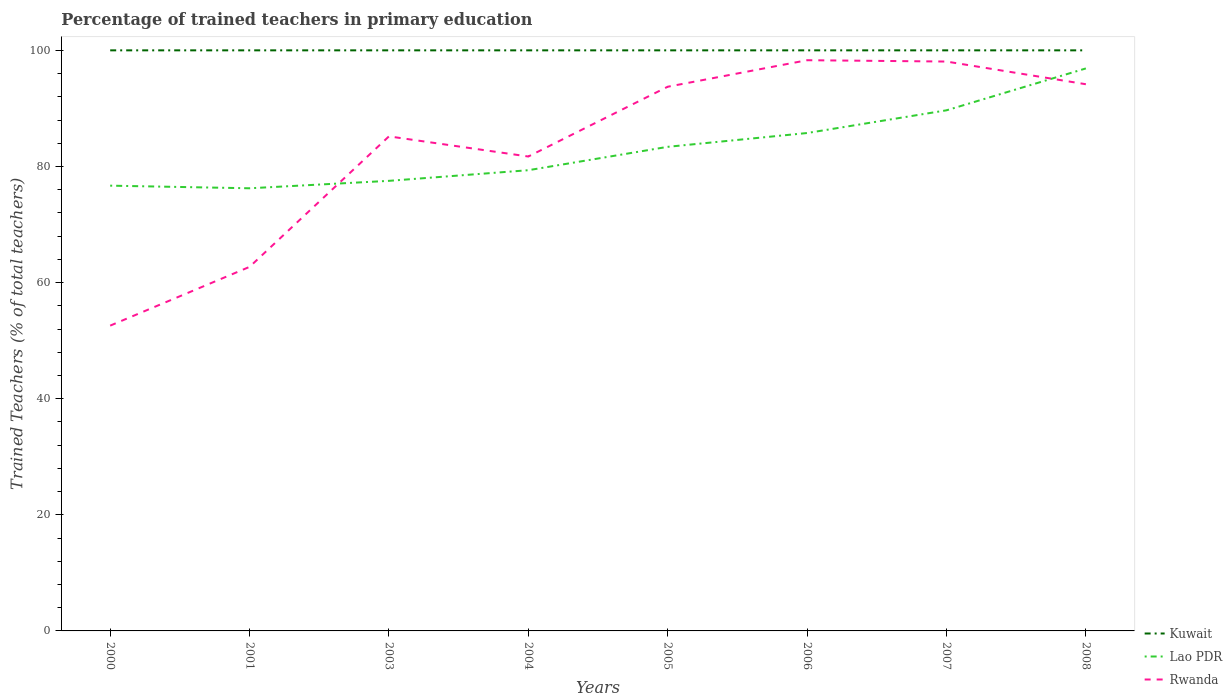Does the line corresponding to Kuwait intersect with the line corresponding to Lao PDR?
Give a very brief answer. No. Is the number of lines equal to the number of legend labels?
Offer a very short reply. Yes. Across all years, what is the maximum percentage of trained teachers in Rwanda?
Ensure brevity in your answer.  52.58. What is the total percentage of trained teachers in Rwanda in the graph?
Make the answer very short. -31.46. What is the difference between the highest and the second highest percentage of trained teachers in Lao PDR?
Your answer should be compact. 20.64. What is the difference between the highest and the lowest percentage of trained teachers in Kuwait?
Make the answer very short. 0. How many lines are there?
Make the answer very short. 3. Are the values on the major ticks of Y-axis written in scientific E-notation?
Offer a terse response. No. Where does the legend appear in the graph?
Make the answer very short. Bottom right. What is the title of the graph?
Offer a very short reply. Percentage of trained teachers in primary education. Does "Latin America(all income levels)" appear as one of the legend labels in the graph?
Give a very brief answer. No. What is the label or title of the Y-axis?
Keep it short and to the point. Trained Teachers (% of total teachers). What is the Trained Teachers (% of total teachers) in Kuwait in 2000?
Offer a very short reply. 100. What is the Trained Teachers (% of total teachers) of Lao PDR in 2000?
Provide a succinct answer. 76.69. What is the Trained Teachers (% of total teachers) of Rwanda in 2000?
Make the answer very short. 52.58. What is the Trained Teachers (% of total teachers) in Kuwait in 2001?
Make the answer very short. 100. What is the Trained Teachers (% of total teachers) in Lao PDR in 2001?
Your answer should be very brief. 76.24. What is the Trained Teachers (% of total teachers) in Rwanda in 2001?
Keep it short and to the point. 62.7. What is the Trained Teachers (% of total teachers) in Kuwait in 2003?
Ensure brevity in your answer.  100. What is the Trained Teachers (% of total teachers) in Lao PDR in 2003?
Offer a very short reply. 77.52. What is the Trained Teachers (% of total teachers) of Rwanda in 2003?
Provide a short and direct response. 85.18. What is the Trained Teachers (% of total teachers) in Lao PDR in 2004?
Offer a very short reply. 79.35. What is the Trained Teachers (% of total teachers) in Rwanda in 2004?
Offer a terse response. 81.71. What is the Trained Teachers (% of total teachers) of Lao PDR in 2005?
Give a very brief answer. 83.38. What is the Trained Teachers (% of total teachers) of Rwanda in 2005?
Give a very brief answer. 93.73. What is the Trained Teachers (% of total teachers) of Lao PDR in 2006?
Ensure brevity in your answer.  85.76. What is the Trained Teachers (% of total teachers) in Rwanda in 2006?
Keep it short and to the point. 98.3. What is the Trained Teachers (% of total teachers) of Kuwait in 2007?
Offer a terse response. 100. What is the Trained Teachers (% of total teachers) in Lao PDR in 2007?
Keep it short and to the point. 89.67. What is the Trained Teachers (% of total teachers) of Rwanda in 2007?
Offer a very short reply. 98.07. What is the Trained Teachers (% of total teachers) in Kuwait in 2008?
Provide a succinct answer. 100. What is the Trained Teachers (% of total teachers) of Lao PDR in 2008?
Provide a short and direct response. 96.89. What is the Trained Teachers (% of total teachers) in Rwanda in 2008?
Provide a succinct answer. 94.16. Across all years, what is the maximum Trained Teachers (% of total teachers) of Lao PDR?
Offer a very short reply. 96.89. Across all years, what is the maximum Trained Teachers (% of total teachers) of Rwanda?
Your answer should be compact. 98.3. Across all years, what is the minimum Trained Teachers (% of total teachers) of Lao PDR?
Give a very brief answer. 76.24. Across all years, what is the minimum Trained Teachers (% of total teachers) in Rwanda?
Ensure brevity in your answer.  52.58. What is the total Trained Teachers (% of total teachers) of Kuwait in the graph?
Your response must be concise. 800. What is the total Trained Teachers (% of total teachers) in Lao PDR in the graph?
Provide a short and direct response. 665.51. What is the total Trained Teachers (% of total teachers) in Rwanda in the graph?
Keep it short and to the point. 666.45. What is the difference between the Trained Teachers (% of total teachers) in Kuwait in 2000 and that in 2001?
Ensure brevity in your answer.  0. What is the difference between the Trained Teachers (% of total teachers) of Lao PDR in 2000 and that in 2001?
Keep it short and to the point. 0.45. What is the difference between the Trained Teachers (% of total teachers) of Rwanda in 2000 and that in 2001?
Offer a terse response. -10.12. What is the difference between the Trained Teachers (% of total teachers) of Lao PDR in 2000 and that in 2003?
Your answer should be very brief. -0.83. What is the difference between the Trained Teachers (% of total teachers) in Rwanda in 2000 and that in 2003?
Offer a very short reply. -32.6. What is the difference between the Trained Teachers (% of total teachers) in Lao PDR in 2000 and that in 2004?
Offer a terse response. -2.66. What is the difference between the Trained Teachers (% of total teachers) of Rwanda in 2000 and that in 2004?
Ensure brevity in your answer.  -29.13. What is the difference between the Trained Teachers (% of total teachers) in Lao PDR in 2000 and that in 2005?
Keep it short and to the point. -6.69. What is the difference between the Trained Teachers (% of total teachers) in Rwanda in 2000 and that in 2005?
Provide a succinct answer. -41.15. What is the difference between the Trained Teachers (% of total teachers) in Lao PDR in 2000 and that in 2006?
Give a very brief answer. -9.07. What is the difference between the Trained Teachers (% of total teachers) of Rwanda in 2000 and that in 2006?
Keep it short and to the point. -45.72. What is the difference between the Trained Teachers (% of total teachers) in Lao PDR in 2000 and that in 2007?
Ensure brevity in your answer.  -12.98. What is the difference between the Trained Teachers (% of total teachers) in Rwanda in 2000 and that in 2007?
Provide a succinct answer. -45.49. What is the difference between the Trained Teachers (% of total teachers) of Kuwait in 2000 and that in 2008?
Your answer should be very brief. 0. What is the difference between the Trained Teachers (% of total teachers) of Lao PDR in 2000 and that in 2008?
Provide a short and direct response. -20.19. What is the difference between the Trained Teachers (% of total teachers) in Rwanda in 2000 and that in 2008?
Keep it short and to the point. -41.58. What is the difference between the Trained Teachers (% of total teachers) of Kuwait in 2001 and that in 2003?
Keep it short and to the point. 0. What is the difference between the Trained Teachers (% of total teachers) in Lao PDR in 2001 and that in 2003?
Offer a terse response. -1.28. What is the difference between the Trained Teachers (% of total teachers) in Rwanda in 2001 and that in 2003?
Ensure brevity in your answer.  -22.48. What is the difference between the Trained Teachers (% of total teachers) of Kuwait in 2001 and that in 2004?
Make the answer very short. 0. What is the difference between the Trained Teachers (% of total teachers) of Lao PDR in 2001 and that in 2004?
Ensure brevity in your answer.  -3.11. What is the difference between the Trained Teachers (% of total teachers) in Rwanda in 2001 and that in 2004?
Ensure brevity in your answer.  -19.01. What is the difference between the Trained Teachers (% of total teachers) in Lao PDR in 2001 and that in 2005?
Give a very brief answer. -7.14. What is the difference between the Trained Teachers (% of total teachers) of Rwanda in 2001 and that in 2005?
Provide a succinct answer. -31.03. What is the difference between the Trained Teachers (% of total teachers) of Kuwait in 2001 and that in 2006?
Offer a very short reply. 0. What is the difference between the Trained Teachers (% of total teachers) in Lao PDR in 2001 and that in 2006?
Provide a succinct answer. -9.52. What is the difference between the Trained Teachers (% of total teachers) in Rwanda in 2001 and that in 2006?
Keep it short and to the point. -35.59. What is the difference between the Trained Teachers (% of total teachers) in Kuwait in 2001 and that in 2007?
Make the answer very short. 0. What is the difference between the Trained Teachers (% of total teachers) of Lao PDR in 2001 and that in 2007?
Provide a succinct answer. -13.43. What is the difference between the Trained Teachers (% of total teachers) of Rwanda in 2001 and that in 2007?
Your response must be concise. -35.37. What is the difference between the Trained Teachers (% of total teachers) in Kuwait in 2001 and that in 2008?
Offer a terse response. 0. What is the difference between the Trained Teachers (% of total teachers) of Lao PDR in 2001 and that in 2008?
Give a very brief answer. -20.64. What is the difference between the Trained Teachers (% of total teachers) in Rwanda in 2001 and that in 2008?
Provide a short and direct response. -31.46. What is the difference between the Trained Teachers (% of total teachers) in Kuwait in 2003 and that in 2004?
Keep it short and to the point. 0. What is the difference between the Trained Teachers (% of total teachers) in Lao PDR in 2003 and that in 2004?
Your response must be concise. -1.83. What is the difference between the Trained Teachers (% of total teachers) in Rwanda in 2003 and that in 2004?
Provide a succinct answer. 3.47. What is the difference between the Trained Teachers (% of total teachers) in Lao PDR in 2003 and that in 2005?
Ensure brevity in your answer.  -5.86. What is the difference between the Trained Teachers (% of total teachers) in Rwanda in 2003 and that in 2005?
Give a very brief answer. -8.55. What is the difference between the Trained Teachers (% of total teachers) in Lao PDR in 2003 and that in 2006?
Your answer should be very brief. -8.24. What is the difference between the Trained Teachers (% of total teachers) of Rwanda in 2003 and that in 2006?
Your answer should be very brief. -13.12. What is the difference between the Trained Teachers (% of total teachers) of Lao PDR in 2003 and that in 2007?
Your answer should be very brief. -12.15. What is the difference between the Trained Teachers (% of total teachers) of Rwanda in 2003 and that in 2007?
Make the answer very short. -12.89. What is the difference between the Trained Teachers (% of total teachers) in Kuwait in 2003 and that in 2008?
Ensure brevity in your answer.  0. What is the difference between the Trained Teachers (% of total teachers) of Lao PDR in 2003 and that in 2008?
Offer a very short reply. -19.36. What is the difference between the Trained Teachers (% of total teachers) of Rwanda in 2003 and that in 2008?
Your answer should be very brief. -8.98. What is the difference between the Trained Teachers (% of total teachers) of Lao PDR in 2004 and that in 2005?
Your response must be concise. -4.03. What is the difference between the Trained Teachers (% of total teachers) in Rwanda in 2004 and that in 2005?
Provide a short and direct response. -12.02. What is the difference between the Trained Teachers (% of total teachers) of Lao PDR in 2004 and that in 2006?
Your answer should be compact. -6.41. What is the difference between the Trained Teachers (% of total teachers) of Rwanda in 2004 and that in 2006?
Provide a short and direct response. -16.59. What is the difference between the Trained Teachers (% of total teachers) of Lao PDR in 2004 and that in 2007?
Your answer should be compact. -10.32. What is the difference between the Trained Teachers (% of total teachers) of Rwanda in 2004 and that in 2007?
Keep it short and to the point. -16.36. What is the difference between the Trained Teachers (% of total teachers) of Kuwait in 2004 and that in 2008?
Ensure brevity in your answer.  0. What is the difference between the Trained Teachers (% of total teachers) of Lao PDR in 2004 and that in 2008?
Offer a terse response. -17.53. What is the difference between the Trained Teachers (% of total teachers) of Rwanda in 2004 and that in 2008?
Offer a terse response. -12.45. What is the difference between the Trained Teachers (% of total teachers) in Kuwait in 2005 and that in 2006?
Provide a succinct answer. 0. What is the difference between the Trained Teachers (% of total teachers) of Lao PDR in 2005 and that in 2006?
Provide a succinct answer. -2.38. What is the difference between the Trained Teachers (% of total teachers) in Rwanda in 2005 and that in 2006?
Provide a succinct answer. -4.57. What is the difference between the Trained Teachers (% of total teachers) of Kuwait in 2005 and that in 2007?
Offer a terse response. 0. What is the difference between the Trained Teachers (% of total teachers) in Lao PDR in 2005 and that in 2007?
Provide a short and direct response. -6.29. What is the difference between the Trained Teachers (% of total teachers) of Rwanda in 2005 and that in 2007?
Ensure brevity in your answer.  -4.34. What is the difference between the Trained Teachers (% of total teachers) in Lao PDR in 2005 and that in 2008?
Ensure brevity in your answer.  -13.5. What is the difference between the Trained Teachers (% of total teachers) of Rwanda in 2005 and that in 2008?
Your response must be concise. -0.43. What is the difference between the Trained Teachers (% of total teachers) of Lao PDR in 2006 and that in 2007?
Make the answer very short. -3.91. What is the difference between the Trained Teachers (% of total teachers) of Rwanda in 2006 and that in 2007?
Give a very brief answer. 0.23. What is the difference between the Trained Teachers (% of total teachers) in Kuwait in 2006 and that in 2008?
Offer a terse response. 0. What is the difference between the Trained Teachers (% of total teachers) of Lao PDR in 2006 and that in 2008?
Your response must be concise. -11.13. What is the difference between the Trained Teachers (% of total teachers) of Rwanda in 2006 and that in 2008?
Keep it short and to the point. 4.14. What is the difference between the Trained Teachers (% of total teachers) of Kuwait in 2007 and that in 2008?
Provide a succinct answer. 0. What is the difference between the Trained Teachers (% of total teachers) in Lao PDR in 2007 and that in 2008?
Offer a terse response. -7.22. What is the difference between the Trained Teachers (% of total teachers) in Rwanda in 2007 and that in 2008?
Offer a very short reply. 3.91. What is the difference between the Trained Teachers (% of total teachers) in Kuwait in 2000 and the Trained Teachers (% of total teachers) in Lao PDR in 2001?
Keep it short and to the point. 23.76. What is the difference between the Trained Teachers (% of total teachers) in Kuwait in 2000 and the Trained Teachers (% of total teachers) in Rwanda in 2001?
Provide a short and direct response. 37.3. What is the difference between the Trained Teachers (% of total teachers) of Lao PDR in 2000 and the Trained Teachers (% of total teachers) of Rwanda in 2001?
Make the answer very short. 13.99. What is the difference between the Trained Teachers (% of total teachers) of Kuwait in 2000 and the Trained Teachers (% of total teachers) of Lao PDR in 2003?
Make the answer very short. 22.48. What is the difference between the Trained Teachers (% of total teachers) in Kuwait in 2000 and the Trained Teachers (% of total teachers) in Rwanda in 2003?
Your answer should be compact. 14.82. What is the difference between the Trained Teachers (% of total teachers) in Lao PDR in 2000 and the Trained Teachers (% of total teachers) in Rwanda in 2003?
Give a very brief answer. -8.49. What is the difference between the Trained Teachers (% of total teachers) in Kuwait in 2000 and the Trained Teachers (% of total teachers) in Lao PDR in 2004?
Your response must be concise. 20.65. What is the difference between the Trained Teachers (% of total teachers) of Kuwait in 2000 and the Trained Teachers (% of total teachers) of Rwanda in 2004?
Your answer should be compact. 18.29. What is the difference between the Trained Teachers (% of total teachers) of Lao PDR in 2000 and the Trained Teachers (% of total teachers) of Rwanda in 2004?
Give a very brief answer. -5.02. What is the difference between the Trained Teachers (% of total teachers) of Kuwait in 2000 and the Trained Teachers (% of total teachers) of Lao PDR in 2005?
Provide a short and direct response. 16.62. What is the difference between the Trained Teachers (% of total teachers) of Kuwait in 2000 and the Trained Teachers (% of total teachers) of Rwanda in 2005?
Your response must be concise. 6.27. What is the difference between the Trained Teachers (% of total teachers) in Lao PDR in 2000 and the Trained Teachers (% of total teachers) in Rwanda in 2005?
Your response must be concise. -17.04. What is the difference between the Trained Teachers (% of total teachers) of Kuwait in 2000 and the Trained Teachers (% of total teachers) of Lao PDR in 2006?
Your answer should be compact. 14.24. What is the difference between the Trained Teachers (% of total teachers) in Kuwait in 2000 and the Trained Teachers (% of total teachers) in Rwanda in 2006?
Your answer should be very brief. 1.7. What is the difference between the Trained Teachers (% of total teachers) in Lao PDR in 2000 and the Trained Teachers (% of total teachers) in Rwanda in 2006?
Provide a short and direct response. -21.61. What is the difference between the Trained Teachers (% of total teachers) of Kuwait in 2000 and the Trained Teachers (% of total teachers) of Lao PDR in 2007?
Keep it short and to the point. 10.33. What is the difference between the Trained Teachers (% of total teachers) of Kuwait in 2000 and the Trained Teachers (% of total teachers) of Rwanda in 2007?
Give a very brief answer. 1.93. What is the difference between the Trained Teachers (% of total teachers) in Lao PDR in 2000 and the Trained Teachers (% of total teachers) in Rwanda in 2007?
Offer a terse response. -21.38. What is the difference between the Trained Teachers (% of total teachers) of Kuwait in 2000 and the Trained Teachers (% of total teachers) of Lao PDR in 2008?
Provide a succinct answer. 3.11. What is the difference between the Trained Teachers (% of total teachers) in Kuwait in 2000 and the Trained Teachers (% of total teachers) in Rwanda in 2008?
Offer a very short reply. 5.84. What is the difference between the Trained Teachers (% of total teachers) in Lao PDR in 2000 and the Trained Teachers (% of total teachers) in Rwanda in 2008?
Your response must be concise. -17.47. What is the difference between the Trained Teachers (% of total teachers) of Kuwait in 2001 and the Trained Teachers (% of total teachers) of Lao PDR in 2003?
Keep it short and to the point. 22.48. What is the difference between the Trained Teachers (% of total teachers) in Kuwait in 2001 and the Trained Teachers (% of total teachers) in Rwanda in 2003?
Your answer should be compact. 14.82. What is the difference between the Trained Teachers (% of total teachers) of Lao PDR in 2001 and the Trained Teachers (% of total teachers) of Rwanda in 2003?
Make the answer very short. -8.94. What is the difference between the Trained Teachers (% of total teachers) in Kuwait in 2001 and the Trained Teachers (% of total teachers) in Lao PDR in 2004?
Provide a short and direct response. 20.65. What is the difference between the Trained Teachers (% of total teachers) in Kuwait in 2001 and the Trained Teachers (% of total teachers) in Rwanda in 2004?
Make the answer very short. 18.29. What is the difference between the Trained Teachers (% of total teachers) in Lao PDR in 2001 and the Trained Teachers (% of total teachers) in Rwanda in 2004?
Keep it short and to the point. -5.47. What is the difference between the Trained Teachers (% of total teachers) in Kuwait in 2001 and the Trained Teachers (% of total teachers) in Lao PDR in 2005?
Your answer should be compact. 16.62. What is the difference between the Trained Teachers (% of total teachers) of Kuwait in 2001 and the Trained Teachers (% of total teachers) of Rwanda in 2005?
Make the answer very short. 6.27. What is the difference between the Trained Teachers (% of total teachers) of Lao PDR in 2001 and the Trained Teachers (% of total teachers) of Rwanda in 2005?
Keep it short and to the point. -17.49. What is the difference between the Trained Teachers (% of total teachers) in Kuwait in 2001 and the Trained Teachers (% of total teachers) in Lao PDR in 2006?
Provide a succinct answer. 14.24. What is the difference between the Trained Teachers (% of total teachers) in Kuwait in 2001 and the Trained Teachers (% of total teachers) in Rwanda in 2006?
Keep it short and to the point. 1.7. What is the difference between the Trained Teachers (% of total teachers) in Lao PDR in 2001 and the Trained Teachers (% of total teachers) in Rwanda in 2006?
Keep it short and to the point. -22.06. What is the difference between the Trained Teachers (% of total teachers) of Kuwait in 2001 and the Trained Teachers (% of total teachers) of Lao PDR in 2007?
Your answer should be very brief. 10.33. What is the difference between the Trained Teachers (% of total teachers) of Kuwait in 2001 and the Trained Teachers (% of total teachers) of Rwanda in 2007?
Make the answer very short. 1.93. What is the difference between the Trained Teachers (% of total teachers) of Lao PDR in 2001 and the Trained Teachers (% of total teachers) of Rwanda in 2007?
Offer a terse response. -21.83. What is the difference between the Trained Teachers (% of total teachers) in Kuwait in 2001 and the Trained Teachers (% of total teachers) in Lao PDR in 2008?
Offer a terse response. 3.11. What is the difference between the Trained Teachers (% of total teachers) of Kuwait in 2001 and the Trained Teachers (% of total teachers) of Rwanda in 2008?
Keep it short and to the point. 5.84. What is the difference between the Trained Teachers (% of total teachers) in Lao PDR in 2001 and the Trained Teachers (% of total teachers) in Rwanda in 2008?
Ensure brevity in your answer.  -17.92. What is the difference between the Trained Teachers (% of total teachers) in Kuwait in 2003 and the Trained Teachers (% of total teachers) in Lao PDR in 2004?
Give a very brief answer. 20.65. What is the difference between the Trained Teachers (% of total teachers) in Kuwait in 2003 and the Trained Teachers (% of total teachers) in Rwanda in 2004?
Your answer should be very brief. 18.29. What is the difference between the Trained Teachers (% of total teachers) of Lao PDR in 2003 and the Trained Teachers (% of total teachers) of Rwanda in 2004?
Keep it short and to the point. -4.19. What is the difference between the Trained Teachers (% of total teachers) in Kuwait in 2003 and the Trained Teachers (% of total teachers) in Lao PDR in 2005?
Provide a short and direct response. 16.62. What is the difference between the Trained Teachers (% of total teachers) of Kuwait in 2003 and the Trained Teachers (% of total teachers) of Rwanda in 2005?
Ensure brevity in your answer.  6.27. What is the difference between the Trained Teachers (% of total teachers) of Lao PDR in 2003 and the Trained Teachers (% of total teachers) of Rwanda in 2005?
Ensure brevity in your answer.  -16.21. What is the difference between the Trained Teachers (% of total teachers) of Kuwait in 2003 and the Trained Teachers (% of total teachers) of Lao PDR in 2006?
Offer a terse response. 14.24. What is the difference between the Trained Teachers (% of total teachers) of Kuwait in 2003 and the Trained Teachers (% of total teachers) of Rwanda in 2006?
Your answer should be compact. 1.7. What is the difference between the Trained Teachers (% of total teachers) in Lao PDR in 2003 and the Trained Teachers (% of total teachers) in Rwanda in 2006?
Make the answer very short. -20.78. What is the difference between the Trained Teachers (% of total teachers) in Kuwait in 2003 and the Trained Teachers (% of total teachers) in Lao PDR in 2007?
Ensure brevity in your answer.  10.33. What is the difference between the Trained Teachers (% of total teachers) of Kuwait in 2003 and the Trained Teachers (% of total teachers) of Rwanda in 2007?
Offer a very short reply. 1.93. What is the difference between the Trained Teachers (% of total teachers) of Lao PDR in 2003 and the Trained Teachers (% of total teachers) of Rwanda in 2007?
Your answer should be very brief. -20.55. What is the difference between the Trained Teachers (% of total teachers) in Kuwait in 2003 and the Trained Teachers (% of total teachers) in Lao PDR in 2008?
Offer a very short reply. 3.11. What is the difference between the Trained Teachers (% of total teachers) in Kuwait in 2003 and the Trained Teachers (% of total teachers) in Rwanda in 2008?
Keep it short and to the point. 5.84. What is the difference between the Trained Teachers (% of total teachers) in Lao PDR in 2003 and the Trained Teachers (% of total teachers) in Rwanda in 2008?
Your answer should be compact. -16.64. What is the difference between the Trained Teachers (% of total teachers) in Kuwait in 2004 and the Trained Teachers (% of total teachers) in Lao PDR in 2005?
Your answer should be compact. 16.62. What is the difference between the Trained Teachers (% of total teachers) of Kuwait in 2004 and the Trained Teachers (% of total teachers) of Rwanda in 2005?
Ensure brevity in your answer.  6.27. What is the difference between the Trained Teachers (% of total teachers) in Lao PDR in 2004 and the Trained Teachers (% of total teachers) in Rwanda in 2005?
Keep it short and to the point. -14.38. What is the difference between the Trained Teachers (% of total teachers) in Kuwait in 2004 and the Trained Teachers (% of total teachers) in Lao PDR in 2006?
Offer a terse response. 14.24. What is the difference between the Trained Teachers (% of total teachers) of Kuwait in 2004 and the Trained Teachers (% of total teachers) of Rwanda in 2006?
Your response must be concise. 1.7. What is the difference between the Trained Teachers (% of total teachers) in Lao PDR in 2004 and the Trained Teachers (% of total teachers) in Rwanda in 2006?
Offer a terse response. -18.95. What is the difference between the Trained Teachers (% of total teachers) of Kuwait in 2004 and the Trained Teachers (% of total teachers) of Lao PDR in 2007?
Make the answer very short. 10.33. What is the difference between the Trained Teachers (% of total teachers) of Kuwait in 2004 and the Trained Teachers (% of total teachers) of Rwanda in 2007?
Your answer should be very brief. 1.93. What is the difference between the Trained Teachers (% of total teachers) in Lao PDR in 2004 and the Trained Teachers (% of total teachers) in Rwanda in 2007?
Make the answer very short. -18.72. What is the difference between the Trained Teachers (% of total teachers) in Kuwait in 2004 and the Trained Teachers (% of total teachers) in Lao PDR in 2008?
Provide a short and direct response. 3.11. What is the difference between the Trained Teachers (% of total teachers) of Kuwait in 2004 and the Trained Teachers (% of total teachers) of Rwanda in 2008?
Provide a short and direct response. 5.84. What is the difference between the Trained Teachers (% of total teachers) in Lao PDR in 2004 and the Trained Teachers (% of total teachers) in Rwanda in 2008?
Make the answer very short. -14.81. What is the difference between the Trained Teachers (% of total teachers) of Kuwait in 2005 and the Trained Teachers (% of total teachers) of Lao PDR in 2006?
Offer a very short reply. 14.24. What is the difference between the Trained Teachers (% of total teachers) of Kuwait in 2005 and the Trained Teachers (% of total teachers) of Rwanda in 2006?
Provide a short and direct response. 1.7. What is the difference between the Trained Teachers (% of total teachers) in Lao PDR in 2005 and the Trained Teachers (% of total teachers) in Rwanda in 2006?
Keep it short and to the point. -14.92. What is the difference between the Trained Teachers (% of total teachers) of Kuwait in 2005 and the Trained Teachers (% of total teachers) of Lao PDR in 2007?
Ensure brevity in your answer.  10.33. What is the difference between the Trained Teachers (% of total teachers) in Kuwait in 2005 and the Trained Teachers (% of total teachers) in Rwanda in 2007?
Keep it short and to the point. 1.93. What is the difference between the Trained Teachers (% of total teachers) of Lao PDR in 2005 and the Trained Teachers (% of total teachers) of Rwanda in 2007?
Offer a terse response. -14.69. What is the difference between the Trained Teachers (% of total teachers) of Kuwait in 2005 and the Trained Teachers (% of total teachers) of Lao PDR in 2008?
Your answer should be compact. 3.11. What is the difference between the Trained Teachers (% of total teachers) in Kuwait in 2005 and the Trained Teachers (% of total teachers) in Rwanda in 2008?
Your answer should be very brief. 5.84. What is the difference between the Trained Teachers (% of total teachers) of Lao PDR in 2005 and the Trained Teachers (% of total teachers) of Rwanda in 2008?
Your answer should be very brief. -10.78. What is the difference between the Trained Teachers (% of total teachers) of Kuwait in 2006 and the Trained Teachers (% of total teachers) of Lao PDR in 2007?
Make the answer very short. 10.33. What is the difference between the Trained Teachers (% of total teachers) in Kuwait in 2006 and the Trained Teachers (% of total teachers) in Rwanda in 2007?
Your response must be concise. 1.93. What is the difference between the Trained Teachers (% of total teachers) in Lao PDR in 2006 and the Trained Teachers (% of total teachers) in Rwanda in 2007?
Your response must be concise. -12.31. What is the difference between the Trained Teachers (% of total teachers) in Kuwait in 2006 and the Trained Teachers (% of total teachers) in Lao PDR in 2008?
Provide a succinct answer. 3.11. What is the difference between the Trained Teachers (% of total teachers) of Kuwait in 2006 and the Trained Teachers (% of total teachers) of Rwanda in 2008?
Make the answer very short. 5.84. What is the difference between the Trained Teachers (% of total teachers) of Lao PDR in 2006 and the Trained Teachers (% of total teachers) of Rwanda in 2008?
Give a very brief answer. -8.4. What is the difference between the Trained Teachers (% of total teachers) of Kuwait in 2007 and the Trained Teachers (% of total teachers) of Lao PDR in 2008?
Your response must be concise. 3.11. What is the difference between the Trained Teachers (% of total teachers) of Kuwait in 2007 and the Trained Teachers (% of total teachers) of Rwanda in 2008?
Make the answer very short. 5.84. What is the difference between the Trained Teachers (% of total teachers) of Lao PDR in 2007 and the Trained Teachers (% of total teachers) of Rwanda in 2008?
Give a very brief answer. -4.49. What is the average Trained Teachers (% of total teachers) of Kuwait per year?
Make the answer very short. 100. What is the average Trained Teachers (% of total teachers) in Lao PDR per year?
Your answer should be very brief. 83.19. What is the average Trained Teachers (% of total teachers) of Rwanda per year?
Offer a very short reply. 83.31. In the year 2000, what is the difference between the Trained Teachers (% of total teachers) of Kuwait and Trained Teachers (% of total teachers) of Lao PDR?
Make the answer very short. 23.31. In the year 2000, what is the difference between the Trained Teachers (% of total teachers) of Kuwait and Trained Teachers (% of total teachers) of Rwanda?
Make the answer very short. 47.42. In the year 2000, what is the difference between the Trained Teachers (% of total teachers) in Lao PDR and Trained Teachers (% of total teachers) in Rwanda?
Your answer should be very brief. 24.11. In the year 2001, what is the difference between the Trained Teachers (% of total teachers) of Kuwait and Trained Teachers (% of total teachers) of Lao PDR?
Offer a terse response. 23.76. In the year 2001, what is the difference between the Trained Teachers (% of total teachers) in Kuwait and Trained Teachers (% of total teachers) in Rwanda?
Provide a succinct answer. 37.3. In the year 2001, what is the difference between the Trained Teachers (% of total teachers) of Lao PDR and Trained Teachers (% of total teachers) of Rwanda?
Give a very brief answer. 13.54. In the year 2003, what is the difference between the Trained Teachers (% of total teachers) in Kuwait and Trained Teachers (% of total teachers) in Lao PDR?
Offer a terse response. 22.48. In the year 2003, what is the difference between the Trained Teachers (% of total teachers) of Kuwait and Trained Teachers (% of total teachers) of Rwanda?
Provide a succinct answer. 14.82. In the year 2003, what is the difference between the Trained Teachers (% of total teachers) of Lao PDR and Trained Teachers (% of total teachers) of Rwanda?
Keep it short and to the point. -7.66. In the year 2004, what is the difference between the Trained Teachers (% of total teachers) of Kuwait and Trained Teachers (% of total teachers) of Lao PDR?
Provide a short and direct response. 20.65. In the year 2004, what is the difference between the Trained Teachers (% of total teachers) in Kuwait and Trained Teachers (% of total teachers) in Rwanda?
Ensure brevity in your answer.  18.29. In the year 2004, what is the difference between the Trained Teachers (% of total teachers) in Lao PDR and Trained Teachers (% of total teachers) in Rwanda?
Keep it short and to the point. -2.36. In the year 2005, what is the difference between the Trained Teachers (% of total teachers) of Kuwait and Trained Teachers (% of total teachers) of Lao PDR?
Your answer should be compact. 16.62. In the year 2005, what is the difference between the Trained Teachers (% of total teachers) in Kuwait and Trained Teachers (% of total teachers) in Rwanda?
Offer a terse response. 6.27. In the year 2005, what is the difference between the Trained Teachers (% of total teachers) of Lao PDR and Trained Teachers (% of total teachers) of Rwanda?
Your response must be concise. -10.35. In the year 2006, what is the difference between the Trained Teachers (% of total teachers) of Kuwait and Trained Teachers (% of total teachers) of Lao PDR?
Your response must be concise. 14.24. In the year 2006, what is the difference between the Trained Teachers (% of total teachers) of Kuwait and Trained Teachers (% of total teachers) of Rwanda?
Your answer should be very brief. 1.7. In the year 2006, what is the difference between the Trained Teachers (% of total teachers) of Lao PDR and Trained Teachers (% of total teachers) of Rwanda?
Make the answer very short. -12.54. In the year 2007, what is the difference between the Trained Teachers (% of total teachers) in Kuwait and Trained Teachers (% of total teachers) in Lao PDR?
Give a very brief answer. 10.33. In the year 2007, what is the difference between the Trained Teachers (% of total teachers) of Kuwait and Trained Teachers (% of total teachers) of Rwanda?
Give a very brief answer. 1.93. In the year 2007, what is the difference between the Trained Teachers (% of total teachers) of Lao PDR and Trained Teachers (% of total teachers) of Rwanda?
Your response must be concise. -8.4. In the year 2008, what is the difference between the Trained Teachers (% of total teachers) in Kuwait and Trained Teachers (% of total teachers) in Lao PDR?
Ensure brevity in your answer.  3.11. In the year 2008, what is the difference between the Trained Teachers (% of total teachers) of Kuwait and Trained Teachers (% of total teachers) of Rwanda?
Your answer should be compact. 5.84. In the year 2008, what is the difference between the Trained Teachers (% of total teachers) in Lao PDR and Trained Teachers (% of total teachers) in Rwanda?
Make the answer very short. 2.72. What is the ratio of the Trained Teachers (% of total teachers) in Lao PDR in 2000 to that in 2001?
Your response must be concise. 1.01. What is the ratio of the Trained Teachers (% of total teachers) of Rwanda in 2000 to that in 2001?
Your answer should be compact. 0.84. What is the ratio of the Trained Teachers (% of total teachers) in Lao PDR in 2000 to that in 2003?
Ensure brevity in your answer.  0.99. What is the ratio of the Trained Teachers (% of total teachers) in Rwanda in 2000 to that in 2003?
Your response must be concise. 0.62. What is the ratio of the Trained Teachers (% of total teachers) in Lao PDR in 2000 to that in 2004?
Provide a short and direct response. 0.97. What is the ratio of the Trained Teachers (% of total teachers) in Rwanda in 2000 to that in 2004?
Your answer should be compact. 0.64. What is the ratio of the Trained Teachers (% of total teachers) of Kuwait in 2000 to that in 2005?
Make the answer very short. 1. What is the ratio of the Trained Teachers (% of total teachers) in Lao PDR in 2000 to that in 2005?
Provide a short and direct response. 0.92. What is the ratio of the Trained Teachers (% of total teachers) of Rwanda in 2000 to that in 2005?
Keep it short and to the point. 0.56. What is the ratio of the Trained Teachers (% of total teachers) of Lao PDR in 2000 to that in 2006?
Your response must be concise. 0.89. What is the ratio of the Trained Teachers (% of total teachers) in Rwanda in 2000 to that in 2006?
Provide a succinct answer. 0.53. What is the ratio of the Trained Teachers (% of total teachers) in Kuwait in 2000 to that in 2007?
Give a very brief answer. 1. What is the ratio of the Trained Teachers (% of total teachers) in Lao PDR in 2000 to that in 2007?
Make the answer very short. 0.86. What is the ratio of the Trained Teachers (% of total teachers) in Rwanda in 2000 to that in 2007?
Provide a succinct answer. 0.54. What is the ratio of the Trained Teachers (% of total teachers) in Lao PDR in 2000 to that in 2008?
Your answer should be very brief. 0.79. What is the ratio of the Trained Teachers (% of total teachers) in Rwanda in 2000 to that in 2008?
Offer a very short reply. 0.56. What is the ratio of the Trained Teachers (% of total teachers) of Kuwait in 2001 to that in 2003?
Ensure brevity in your answer.  1. What is the ratio of the Trained Teachers (% of total teachers) in Lao PDR in 2001 to that in 2003?
Give a very brief answer. 0.98. What is the ratio of the Trained Teachers (% of total teachers) in Rwanda in 2001 to that in 2003?
Provide a short and direct response. 0.74. What is the ratio of the Trained Teachers (% of total teachers) of Kuwait in 2001 to that in 2004?
Keep it short and to the point. 1. What is the ratio of the Trained Teachers (% of total teachers) of Lao PDR in 2001 to that in 2004?
Make the answer very short. 0.96. What is the ratio of the Trained Teachers (% of total teachers) in Rwanda in 2001 to that in 2004?
Provide a succinct answer. 0.77. What is the ratio of the Trained Teachers (% of total teachers) in Kuwait in 2001 to that in 2005?
Keep it short and to the point. 1. What is the ratio of the Trained Teachers (% of total teachers) in Lao PDR in 2001 to that in 2005?
Make the answer very short. 0.91. What is the ratio of the Trained Teachers (% of total teachers) of Rwanda in 2001 to that in 2005?
Give a very brief answer. 0.67. What is the ratio of the Trained Teachers (% of total teachers) of Kuwait in 2001 to that in 2006?
Keep it short and to the point. 1. What is the ratio of the Trained Teachers (% of total teachers) of Lao PDR in 2001 to that in 2006?
Provide a succinct answer. 0.89. What is the ratio of the Trained Teachers (% of total teachers) of Rwanda in 2001 to that in 2006?
Provide a short and direct response. 0.64. What is the ratio of the Trained Teachers (% of total teachers) in Kuwait in 2001 to that in 2007?
Offer a very short reply. 1. What is the ratio of the Trained Teachers (% of total teachers) of Lao PDR in 2001 to that in 2007?
Provide a short and direct response. 0.85. What is the ratio of the Trained Teachers (% of total teachers) of Rwanda in 2001 to that in 2007?
Provide a short and direct response. 0.64. What is the ratio of the Trained Teachers (% of total teachers) in Kuwait in 2001 to that in 2008?
Give a very brief answer. 1. What is the ratio of the Trained Teachers (% of total teachers) of Lao PDR in 2001 to that in 2008?
Your answer should be very brief. 0.79. What is the ratio of the Trained Teachers (% of total teachers) of Rwanda in 2001 to that in 2008?
Your response must be concise. 0.67. What is the ratio of the Trained Teachers (% of total teachers) in Kuwait in 2003 to that in 2004?
Ensure brevity in your answer.  1. What is the ratio of the Trained Teachers (% of total teachers) of Lao PDR in 2003 to that in 2004?
Give a very brief answer. 0.98. What is the ratio of the Trained Teachers (% of total teachers) in Rwanda in 2003 to that in 2004?
Provide a succinct answer. 1.04. What is the ratio of the Trained Teachers (% of total teachers) of Kuwait in 2003 to that in 2005?
Provide a succinct answer. 1. What is the ratio of the Trained Teachers (% of total teachers) of Lao PDR in 2003 to that in 2005?
Your answer should be compact. 0.93. What is the ratio of the Trained Teachers (% of total teachers) in Rwanda in 2003 to that in 2005?
Your answer should be compact. 0.91. What is the ratio of the Trained Teachers (% of total teachers) of Kuwait in 2003 to that in 2006?
Provide a short and direct response. 1. What is the ratio of the Trained Teachers (% of total teachers) in Lao PDR in 2003 to that in 2006?
Give a very brief answer. 0.9. What is the ratio of the Trained Teachers (% of total teachers) of Rwanda in 2003 to that in 2006?
Keep it short and to the point. 0.87. What is the ratio of the Trained Teachers (% of total teachers) of Lao PDR in 2003 to that in 2007?
Your answer should be very brief. 0.86. What is the ratio of the Trained Teachers (% of total teachers) of Rwanda in 2003 to that in 2007?
Offer a terse response. 0.87. What is the ratio of the Trained Teachers (% of total teachers) in Lao PDR in 2003 to that in 2008?
Your answer should be very brief. 0.8. What is the ratio of the Trained Teachers (% of total teachers) in Rwanda in 2003 to that in 2008?
Keep it short and to the point. 0.9. What is the ratio of the Trained Teachers (% of total teachers) of Lao PDR in 2004 to that in 2005?
Ensure brevity in your answer.  0.95. What is the ratio of the Trained Teachers (% of total teachers) in Rwanda in 2004 to that in 2005?
Your answer should be compact. 0.87. What is the ratio of the Trained Teachers (% of total teachers) of Lao PDR in 2004 to that in 2006?
Your answer should be very brief. 0.93. What is the ratio of the Trained Teachers (% of total teachers) in Rwanda in 2004 to that in 2006?
Your response must be concise. 0.83. What is the ratio of the Trained Teachers (% of total teachers) in Lao PDR in 2004 to that in 2007?
Offer a very short reply. 0.88. What is the ratio of the Trained Teachers (% of total teachers) in Rwanda in 2004 to that in 2007?
Give a very brief answer. 0.83. What is the ratio of the Trained Teachers (% of total teachers) of Kuwait in 2004 to that in 2008?
Provide a short and direct response. 1. What is the ratio of the Trained Teachers (% of total teachers) in Lao PDR in 2004 to that in 2008?
Your answer should be compact. 0.82. What is the ratio of the Trained Teachers (% of total teachers) in Rwanda in 2004 to that in 2008?
Make the answer very short. 0.87. What is the ratio of the Trained Teachers (% of total teachers) of Lao PDR in 2005 to that in 2006?
Your answer should be very brief. 0.97. What is the ratio of the Trained Teachers (% of total teachers) of Rwanda in 2005 to that in 2006?
Make the answer very short. 0.95. What is the ratio of the Trained Teachers (% of total teachers) of Lao PDR in 2005 to that in 2007?
Make the answer very short. 0.93. What is the ratio of the Trained Teachers (% of total teachers) in Rwanda in 2005 to that in 2007?
Ensure brevity in your answer.  0.96. What is the ratio of the Trained Teachers (% of total teachers) in Kuwait in 2005 to that in 2008?
Offer a terse response. 1. What is the ratio of the Trained Teachers (% of total teachers) of Lao PDR in 2005 to that in 2008?
Make the answer very short. 0.86. What is the ratio of the Trained Teachers (% of total teachers) of Rwanda in 2005 to that in 2008?
Provide a succinct answer. 1. What is the ratio of the Trained Teachers (% of total teachers) of Kuwait in 2006 to that in 2007?
Keep it short and to the point. 1. What is the ratio of the Trained Teachers (% of total teachers) of Lao PDR in 2006 to that in 2007?
Keep it short and to the point. 0.96. What is the ratio of the Trained Teachers (% of total teachers) of Rwanda in 2006 to that in 2007?
Give a very brief answer. 1. What is the ratio of the Trained Teachers (% of total teachers) of Kuwait in 2006 to that in 2008?
Provide a short and direct response. 1. What is the ratio of the Trained Teachers (% of total teachers) of Lao PDR in 2006 to that in 2008?
Offer a terse response. 0.89. What is the ratio of the Trained Teachers (% of total teachers) of Rwanda in 2006 to that in 2008?
Provide a succinct answer. 1.04. What is the ratio of the Trained Teachers (% of total teachers) of Kuwait in 2007 to that in 2008?
Keep it short and to the point. 1. What is the ratio of the Trained Teachers (% of total teachers) in Lao PDR in 2007 to that in 2008?
Ensure brevity in your answer.  0.93. What is the ratio of the Trained Teachers (% of total teachers) of Rwanda in 2007 to that in 2008?
Offer a terse response. 1.04. What is the difference between the highest and the second highest Trained Teachers (% of total teachers) of Kuwait?
Offer a terse response. 0. What is the difference between the highest and the second highest Trained Teachers (% of total teachers) of Lao PDR?
Ensure brevity in your answer.  7.22. What is the difference between the highest and the second highest Trained Teachers (% of total teachers) in Rwanda?
Keep it short and to the point. 0.23. What is the difference between the highest and the lowest Trained Teachers (% of total teachers) in Lao PDR?
Provide a short and direct response. 20.64. What is the difference between the highest and the lowest Trained Teachers (% of total teachers) in Rwanda?
Give a very brief answer. 45.72. 